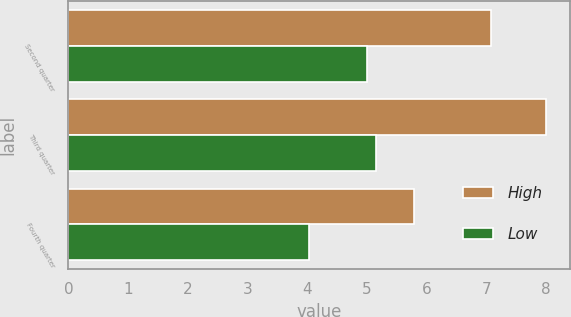<chart> <loc_0><loc_0><loc_500><loc_500><stacked_bar_chart><ecel><fcel>Second quarter<fcel>Third quarter<fcel>Fourth quarter<nl><fcel>High<fcel>7.09<fcel>8<fcel>5.8<nl><fcel>Low<fcel>5.01<fcel>5.15<fcel>4.03<nl></chart> 